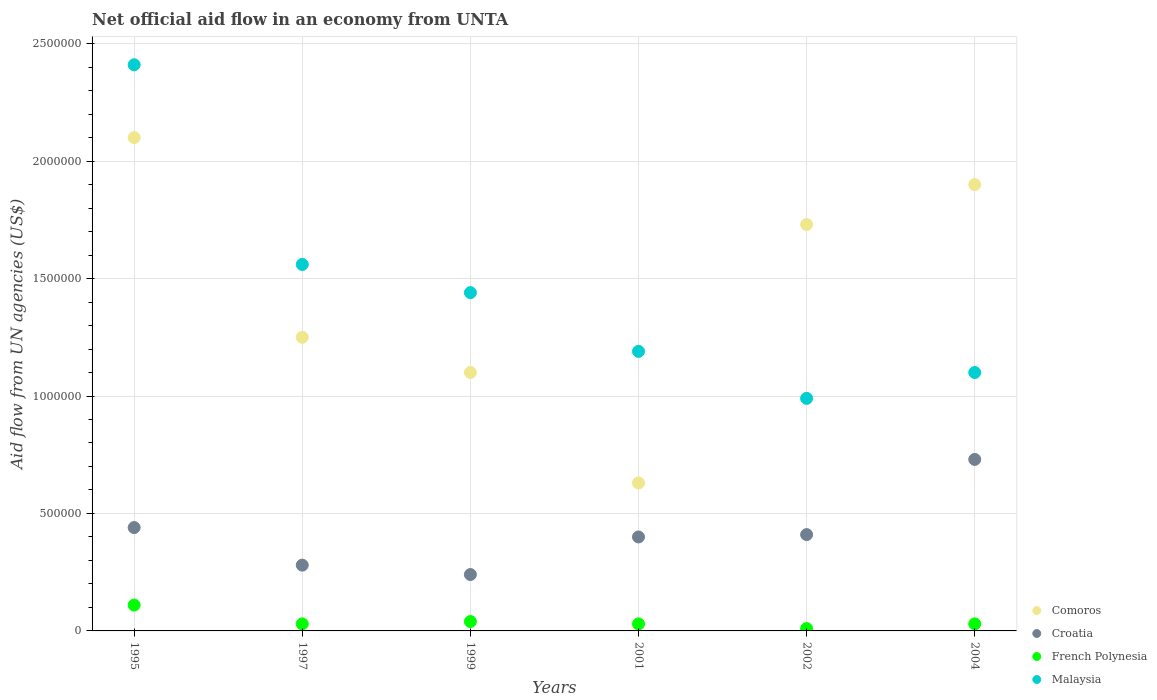How many different coloured dotlines are there?
Keep it short and to the point. 4. Is the number of dotlines equal to the number of legend labels?
Keep it short and to the point. Yes. Across all years, what is the maximum net official aid flow in Malaysia?
Your answer should be compact. 2.41e+06. Across all years, what is the minimum net official aid flow in Malaysia?
Your response must be concise. 9.90e+05. In which year was the net official aid flow in French Polynesia maximum?
Provide a short and direct response. 1995. In which year was the net official aid flow in French Polynesia minimum?
Provide a succinct answer. 2002. What is the total net official aid flow in Comoros in the graph?
Offer a very short reply. 8.71e+06. What is the difference between the net official aid flow in Malaysia in 2001 and that in 2004?
Keep it short and to the point. 9.00e+04. What is the difference between the net official aid flow in French Polynesia in 2004 and the net official aid flow in Malaysia in 1995?
Your response must be concise. -2.38e+06. What is the average net official aid flow in Croatia per year?
Your answer should be compact. 4.17e+05. In the year 1995, what is the difference between the net official aid flow in Croatia and net official aid flow in Comoros?
Provide a short and direct response. -1.66e+06. What is the ratio of the net official aid flow in Malaysia in 1999 to that in 2004?
Keep it short and to the point. 1.31. Is the net official aid flow in Croatia in 1999 less than that in 2004?
Provide a short and direct response. Yes. Is the difference between the net official aid flow in Croatia in 1995 and 2002 greater than the difference between the net official aid flow in Comoros in 1995 and 2002?
Offer a very short reply. No. What is the difference between the highest and the second highest net official aid flow in French Polynesia?
Your answer should be very brief. 7.00e+04. Is the sum of the net official aid flow in Malaysia in 1997 and 2001 greater than the maximum net official aid flow in Croatia across all years?
Your answer should be compact. Yes. Is it the case that in every year, the sum of the net official aid flow in Comoros and net official aid flow in French Polynesia  is greater than the sum of net official aid flow in Malaysia and net official aid flow in Croatia?
Ensure brevity in your answer.  No. How many years are there in the graph?
Your answer should be very brief. 6. What is the difference between two consecutive major ticks on the Y-axis?
Your answer should be very brief. 5.00e+05. Are the values on the major ticks of Y-axis written in scientific E-notation?
Your answer should be very brief. No. Does the graph contain grids?
Provide a short and direct response. Yes. Where does the legend appear in the graph?
Offer a terse response. Bottom right. How many legend labels are there?
Provide a succinct answer. 4. How are the legend labels stacked?
Provide a short and direct response. Vertical. What is the title of the graph?
Keep it short and to the point. Net official aid flow in an economy from UNTA. What is the label or title of the X-axis?
Provide a short and direct response. Years. What is the label or title of the Y-axis?
Provide a succinct answer. Aid flow from UN agencies (US$). What is the Aid flow from UN agencies (US$) of Comoros in 1995?
Make the answer very short. 2.10e+06. What is the Aid flow from UN agencies (US$) of Malaysia in 1995?
Make the answer very short. 2.41e+06. What is the Aid flow from UN agencies (US$) in Comoros in 1997?
Your answer should be compact. 1.25e+06. What is the Aid flow from UN agencies (US$) in French Polynesia in 1997?
Provide a succinct answer. 3.00e+04. What is the Aid flow from UN agencies (US$) of Malaysia in 1997?
Your response must be concise. 1.56e+06. What is the Aid flow from UN agencies (US$) in Comoros in 1999?
Your response must be concise. 1.10e+06. What is the Aid flow from UN agencies (US$) in Croatia in 1999?
Your response must be concise. 2.40e+05. What is the Aid flow from UN agencies (US$) of Malaysia in 1999?
Your answer should be very brief. 1.44e+06. What is the Aid flow from UN agencies (US$) in Comoros in 2001?
Give a very brief answer. 6.30e+05. What is the Aid flow from UN agencies (US$) in Croatia in 2001?
Provide a succinct answer. 4.00e+05. What is the Aid flow from UN agencies (US$) of Malaysia in 2001?
Your answer should be very brief. 1.19e+06. What is the Aid flow from UN agencies (US$) of Comoros in 2002?
Your answer should be compact. 1.73e+06. What is the Aid flow from UN agencies (US$) of Croatia in 2002?
Your answer should be compact. 4.10e+05. What is the Aid flow from UN agencies (US$) in Malaysia in 2002?
Offer a terse response. 9.90e+05. What is the Aid flow from UN agencies (US$) in Comoros in 2004?
Provide a short and direct response. 1.90e+06. What is the Aid flow from UN agencies (US$) of Croatia in 2004?
Give a very brief answer. 7.30e+05. What is the Aid flow from UN agencies (US$) in French Polynesia in 2004?
Ensure brevity in your answer.  3.00e+04. What is the Aid flow from UN agencies (US$) in Malaysia in 2004?
Give a very brief answer. 1.10e+06. Across all years, what is the maximum Aid flow from UN agencies (US$) of Comoros?
Your answer should be very brief. 2.10e+06. Across all years, what is the maximum Aid flow from UN agencies (US$) of Croatia?
Keep it short and to the point. 7.30e+05. Across all years, what is the maximum Aid flow from UN agencies (US$) of French Polynesia?
Your answer should be very brief. 1.10e+05. Across all years, what is the maximum Aid flow from UN agencies (US$) in Malaysia?
Keep it short and to the point. 2.41e+06. Across all years, what is the minimum Aid flow from UN agencies (US$) of Comoros?
Give a very brief answer. 6.30e+05. Across all years, what is the minimum Aid flow from UN agencies (US$) of Croatia?
Give a very brief answer. 2.40e+05. Across all years, what is the minimum Aid flow from UN agencies (US$) of Malaysia?
Your answer should be very brief. 9.90e+05. What is the total Aid flow from UN agencies (US$) in Comoros in the graph?
Provide a short and direct response. 8.71e+06. What is the total Aid flow from UN agencies (US$) in Croatia in the graph?
Keep it short and to the point. 2.50e+06. What is the total Aid flow from UN agencies (US$) in Malaysia in the graph?
Offer a terse response. 8.69e+06. What is the difference between the Aid flow from UN agencies (US$) of Comoros in 1995 and that in 1997?
Ensure brevity in your answer.  8.50e+05. What is the difference between the Aid flow from UN agencies (US$) of Malaysia in 1995 and that in 1997?
Offer a very short reply. 8.50e+05. What is the difference between the Aid flow from UN agencies (US$) of Croatia in 1995 and that in 1999?
Provide a short and direct response. 2.00e+05. What is the difference between the Aid flow from UN agencies (US$) in French Polynesia in 1995 and that in 1999?
Ensure brevity in your answer.  7.00e+04. What is the difference between the Aid flow from UN agencies (US$) of Malaysia in 1995 and that in 1999?
Ensure brevity in your answer.  9.70e+05. What is the difference between the Aid flow from UN agencies (US$) of Comoros in 1995 and that in 2001?
Your answer should be compact. 1.47e+06. What is the difference between the Aid flow from UN agencies (US$) of Croatia in 1995 and that in 2001?
Your response must be concise. 4.00e+04. What is the difference between the Aid flow from UN agencies (US$) of French Polynesia in 1995 and that in 2001?
Keep it short and to the point. 8.00e+04. What is the difference between the Aid flow from UN agencies (US$) in Malaysia in 1995 and that in 2001?
Ensure brevity in your answer.  1.22e+06. What is the difference between the Aid flow from UN agencies (US$) of Comoros in 1995 and that in 2002?
Your answer should be compact. 3.70e+05. What is the difference between the Aid flow from UN agencies (US$) in Croatia in 1995 and that in 2002?
Ensure brevity in your answer.  3.00e+04. What is the difference between the Aid flow from UN agencies (US$) of French Polynesia in 1995 and that in 2002?
Your answer should be compact. 1.00e+05. What is the difference between the Aid flow from UN agencies (US$) in Malaysia in 1995 and that in 2002?
Provide a short and direct response. 1.42e+06. What is the difference between the Aid flow from UN agencies (US$) of Comoros in 1995 and that in 2004?
Your response must be concise. 2.00e+05. What is the difference between the Aid flow from UN agencies (US$) in French Polynesia in 1995 and that in 2004?
Make the answer very short. 8.00e+04. What is the difference between the Aid flow from UN agencies (US$) in Malaysia in 1995 and that in 2004?
Make the answer very short. 1.31e+06. What is the difference between the Aid flow from UN agencies (US$) of Croatia in 1997 and that in 1999?
Make the answer very short. 4.00e+04. What is the difference between the Aid flow from UN agencies (US$) of Malaysia in 1997 and that in 1999?
Keep it short and to the point. 1.20e+05. What is the difference between the Aid flow from UN agencies (US$) of Comoros in 1997 and that in 2001?
Give a very brief answer. 6.20e+05. What is the difference between the Aid flow from UN agencies (US$) of French Polynesia in 1997 and that in 2001?
Provide a succinct answer. 0. What is the difference between the Aid flow from UN agencies (US$) in Malaysia in 1997 and that in 2001?
Ensure brevity in your answer.  3.70e+05. What is the difference between the Aid flow from UN agencies (US$) of Comoros in 1997 and that in 2002?
Ensure brevity in your answer.  -4.80e+05. What is the difference between the Aid flow from UN agencies (US$) of French Polynesia in 1997 and that in 2002?
Give a very brief answer. 2.00e+04. What is the difference between the Aid flow from UN agencies (US$) in Malaysia in 1997 and that in 2002?
Provide a succinct answer. 5.70e+05. What is the difference between the Aid flow from UN agencies (US$) of Comoros in 1997 and that in 2004?
Your answer should be compact. -6.50e+05. What is the difference between the Aid flow from UN agencies (US$) of Croatia in 1997 and that in 2004?
Keep it short and to the point. -4.50e+05. What is the difference between the Aid flow from UN agencies (US$) of Comoros in 1999 and that in 2002?
Provide a succinct answer. -6.30e+05. What is the difference between the Aid flow from UN agencies (US$) of Malaysia in 1999 and that in 2002?
Keep it short and to the point. 4.50e+05. What is the difference between the Aid flow from UN agencies (US$) of Comoros in 1999 and that in 2004?
Provide a succinct answer. -8.00e+05. What is the difference between the Aid flow from UN agencies (US$) of Croatia in 1999 and that in 2004?
Provide a succinct answer. -4.90e+05. What is the difference between the Aid flow from UN agencies (US$) of French Polynesia in 1999 and that in 2004?
Make the answer very short. 10000. What is the difference between the Aid flow from UN agencies (US$) in Malaysia in 1999 and that in 2004?
Your answer should be very brief. 3.40e+05. What is the difference between the Aid flow from UN agencies (US$) of Comoros in 2001 and that in 2002?
Provide a succinct answer. -1.10e+06. What is the difference between the Aid flow from UN agencies (US$) of French Polynesia in 2001 and that in 2002?
Make the answer very short. 2.00e+04. What is the difference between the Aid flow from UN agencies (US$) in Comoros in 2001 and that in 2004?
Provide a short and direct response. -1.27e+06. What is the difference between the Aid flow from UN agencies (US$) in Croatia in 2001 and that in 2004?
Your answer should be compact. -3.30e+05. What is the difference between the Aid flow from UN agencies (US$) of French Polynesia in 2001 and that in 2004?
Provide a succinct answer. 0. What is the difference between the Aid flow from UN agencies (US$) of Malaysia in 2001 and that in 2004?
Ensure brevity in your answer.  9.00e+04. What is the difference between the Aid flow from UN agencies (US$) in Comoros in 2002 and that in 2004?
Give a very brief answer. -1.70e+05. What is the difference between the Aid flow from UN agencies (US$) of Croatia in 2002 and that in 2004?
Give a very brief answer. -3.20e+05. What is the difference between the Aid flow from UN agencies (US$) of Comoros in 1995 and the Aid flow from UN agencies (US$) of Croatia in 1997?
Offer a very short reply. 1.82e+06. What is the difference between the Aid flow from UN agencies (US$) of Comoros in 1995 and the Aid flow from UN agencies (US$) of French Polynesia in 1997?
Your answer should be compact. 2.07e+06. What is the difference between the Aid flow from UN agencies (US$) of Comoros in 1995 and the Aid flow from UN agencies (US$) of Malaysia in 1997?
Offer a very short reply. 5.40e+05. What is the difference between the Aid flow from UN agencies (US$) of Croatia in 1995 and the Aid flow from UN agencies (US$) of French Polynesia in 1997?
Your answer should be compact. 4.10e+05. What is the difference between the Aid flow from UN agencies (US$) in Croatia in 1995 and the Aid flow from UN agencies (US$) in Malaysia in 1997?
Your answer should be compact. -1.12e+06. What is the difference between the Aid flow from UN agencies (US$) in French Polynesia in 1995 and the Aid flow from UN agencies (US$) in Malaysia in 1997?
Make the answer very short. -1.45e+06. What is the difference between the Aid flow from UN agencies (US$) in Comoros in 1995 and the Aid flow from UN agencies (US$) in Croatia in 1999?
Provide a succinct answer. 1.86e+06. What is the difference between the Aid flow from UN agencies (US$) of Comoros in 1995 and the Aid flow from UN agencies (US$) of French Polynesia in 1999?
Provide a succinct answer. 2.06e+06. What is the difference between the Aid flow from UN agencies (US$) in Comoros in 1995 and the Aid flow from UN agencies (US$) in Malaysia in 1999?
Provide a succinct answer. 6.60e+05. What is the difference between the Aid flow from UN agencies (US$) of Croatia in 1995 and the Aid flow from UN agencies (US$) of French Polynesia in 1999?
Give a very brief answer. 4.00e+05. What is the difference between the Aid flow from UN agencies (US$) in French Polynesia in 1995 and the Aid flow from UN agencies (US$) in Malaysia in 1999?
Provide a succinct answer. -1.33e+06. What is the difference between the Aid flow from UN agencies (US$) of Comoros in 1995 and the Aid flow from UN agencies (US$) of Croatia in 2001?
Make the answer very short. 1.70e+06. What is the difference between the Aid flow from UN agencies (US$) of Comoros in 1995 and the Aid flow from UN agencies (US$) of French Polynesia in 2001?
Keep it short and to the point. 2.07e+06. What is the difference between the Aid flow from UN agencies (US$) in Comoros in 1995 and the Aid flow from UN agencies (US$) in Malaysia in 2001?
Offer a very short reply. 9.10e+05. What is the difference between the Aid flow from UN agencies (US$) of Croatia in 1995 and the Aid flow from UN agencies (US$) of French Polynesia in 2001?
Offer a very short reply. 4.10e+05. What is the difference between the Aid flow from UN agencies (US$) in Croatia in 1995 and the Aid flow from UN agencies (US$) in Malaysia in 2001?
Your answer should be compact. -7.50e+05. What is the difference between the Aid flow from UN agencies (US$) of French Polynesia in 1995 and the Aid flow from UN agencies (US$) of Malaysia in 2001?
Your answer should be compact. -1.08e+06. What is the difference between the Aid flow from UN agencies (US$) in Comoros in 1995 and the Aid flow from UN agencies (US$) in Croatia in 2002?
Your answer should be compact. 1.69e+06. What is the difference between the Aid flow from UN agencies (US$) in Comoros in 1995 and the Aid flow from UN agencies (US$) in French Polynesia in 2002?
Make the answer very short. 2.09e+06. What is the difference between the Aid flow from UN agencies (US$) in Comoros in 1995 and the Aid flow from UN agencies (US$) in Malaysia in 2002?
Make the answer very short. 1.11e+06. What is the difference between the Aid flow from UN agencies (US$) in Croatia in 1995 and the Aid flow from UN agencies (US$) in Malaysia in 2002?
Your answer should be very brief. -5.50e+05. What is the difference between the Aid flow from UN agencies (US$) of French Polynesia in 1995 and the Aid flow from UN agencies (US$) of Malaysia in 2002?
Your answer should be very brief. -8.80e+05. What is the difference between the Aid flow from UN agencies (US$) in Comoros in 1995 and the Aid flow from UN agencies (US$) in Croatia in 2004?
Offer a terse response. 1.37e+06. What is the difference between the Aid flow from UN agencies (US$) in Comoros in 1995 and the Aid flow from UN agencies (US$) in French Polynesia in 2004?
Your answer should be compact. 2.07e+06. What is the difference between the Aid flow from UN agencies (US$) of Croatia in 1995 and the Aid flow from UN agencies (US$) of French Polynesia in 2004?
Your response must be concise. 4.10e+05. What is the difference between the Aid flow from UN agencies (US$) of Croatia in 1995 and the Aid flow from UN agencies (US$) of Malaysia in 2004?
Your answer should be very brief. -6.60e+05. What is the difference between the Aid flow from UN agencies (US$) of French Polynesia in 1995 and the Aid flow from UN agencies (US$) of Malaysia in 2004?
Your response must be concise. -9.90e+05. What is the difference between the Aid flow from UN agencies (US$) of Comoros in 1997 and the Aid flow from UN agencies (US$) of Croatia in 1999?
Provide a succinct answer. 1.01e+06. What is the difference between the Aid flow from UN agencies (US$) of Comoros in 1997 and the Aid flow from UN agencies (US$) of French Polynesia in 1999?
Your answer should be compact. 1.21e+06. What is the difference between the Aid flow from UN agencies (US$) of Comoros in 1997 and the Aid flow from UN agencies (US$) of Malaysia in 1999?
Your response must be concise. -1.90e+05. What is the difference between the Aid flow from UN agencies (US$) of Croatia in 1997 and the Aid flow from UN agencies (US$) of Malaysia in 1999?
Provide a short and direct response. -1.16e+06. What is the difference between the Aid flow from UN agencies (US$) of French Polynesia in 1997 and the Aid flow from UN agencies (US$) of Malaysia in 1999?
Provide a succinct answer. -1.41e+06. What is the difference between the Aid flow from UN agencies (US$) in Comoros in 1997 and the Aid flow from UN agencies (US$) in Croatia in 2001?
Provide a short and direct response. 8.50e+05. What is the difference between the Aid flow from UN agencies (US$) in Comoros in 1997 and the Aid flow from UN agencies (US$) in French Polynesia in 2001?
Provide a succinct answer. 1.22e+06. What is the difference between the Aid flow from UN agencies (US$) in Croatia in 1997 and the Aid flow from UN agencies (US$) in Malaysia in 2001?
Make the answer very short. -9.10e+05. What is the difference between the Aid flow from UN agencies (US$) of French Polynesia in 1997 and the Aid flow from UN agencies (US$) of Malaysia in 2001?
Your response must be concise. -1.16e+06. What is the difference between the Aid flow from UN agencies (US$) in Comoros in 1997 and the Aid flow from UN agencies (US$) in Croatia in 2002?
Provide a short and direct response. 8.40e+05. What is the difference between the Aid flow from UN agencies (US$) in Comoros in 1997 and the Aid flow from UN agencies (US$) in French Polynesia in 2002?
Offer a terse response. 1.24e+06. What is the difference between the Aid flow from UN agencies (US$) of Comoros in 1997 and the Aid flow from UN agencies (US$) of Malaysia in 2002?
Ensure brevity in your answer.  2.60e+05. What is the difference between the Aid flow from UN agencies (US$) of Croatia in 1997 and the Aid flow from UN agencies (US$) of French Polynesia in 2002?
Make the answer very short. 2.70e+05. What is the difference between the Aid flow from UN agencies (US$) of Croatia in 1997 and the Aid flow from UN agencies (US$) of Malaysia in 2002?
Make the answer very short. -7.10e+05. What is the difference between the Aid flow from UN agencies (US$) in French Polynesia in 1997 and the Aid flow from UN agencies (US$) in Malaysia in 2002?
Keep it short and to the point. -9.60e+05. What is the difference between the Aid flow from UN agencies (US$) in Comoros in 1997 and the Aid flow from UN agencies (US$) in Croatia in 2004?
Your answer should be compact. 5.20e+05. What is the difference between the Aid flow from UN agencies (US$) of Comoros in 1997 and the Aid flow from UN agencies (US$) of French Polynesia in 2004?
Keep it short and to the point. 1.22e+06. What is the difference between the Aid flow from UN agencies (US$) in Croatia in 1997 and the Aid flow from UN agencies (US$) in French Polynesia in 2004?
Make the answer very short. 2.50e+05. What is the difference between the Aid flow from UN agencies (US$) in Croatia in 1997 and the Aid flow from UN agencies (US$) in Malaysia in 2004?
Ensure brevity in your answer.  -8.20e+05. What is the difference between the Aid flow from UN agencies (US$) of French Polynesia in 1997 and the Aid flow from UN agencies (US$) of Malaysia in 2004?
Your response must be concise. -1.07e+06. What is the difference between the Aid flow from UN agencies (US$) of Comoros in 1999 and the Aid flow from UN agencies (US$) of French Polynesia in 2001?
Offer a terse response. 1.07e+06. What is the difference between the Aid flow from UN agencies (US$) in Croatia in 1999 and the Aid flow from UN agencies (US$) in Malaysia in 2001?
Offer a very short reply. -9.50e+05. What is the difference between the Aid flow from UN agencies (US$) of French Polynesia in 1999 and the Aid flow from UN agencies (US$) of Malaysia in 2001?
Make the answer very short. -1.15e+06. What is the difference between the Aid flow from UN agencies (US$) in Comoros in 1999 and the Aid flow from UN agencies (US$) in Croatia in 2002?
Your answer should be compact. 6.90e+05. What is the difference between the Aid flow from UN agencies (US$) of Comoros in 1999 and the Aid flow from UN agencies (US$) of French Polynesia in 2002?
Your answer should be very brief. 1.09e+06. What is the difference between the Aid flow from UN agencies (US$) in Croatia in 1999 and the Aid flow from UN agencies (US$) in French Polynesia in 2002?
Provide a short and direct response. 2.30e+05. What is the difference between the Aid flow from UN agencies (US$) in Croatia in 1999 and the Aid flow from UN agencies (US$) in Malaysia in 2002?
Your answer should be compact. -7.50e+05. What is the difference between the Aid flow from UN agencies (US$) in French Polynesia in 1999 and the Aid flow from UN agencies (US$) in Malaysia in 2002?
Give a very brief answer. -9.50e+05. What is the difference between the Aid flow from UN agencies (US$) in Comoros in 1999 and the Aid flow from UN agencies (US$) in Croatia in 2004?
Make the answer very short. 3.70e+05. What is the difference between the Aid flow from UN agencies (US$) of Comoros in 1999 and the Aid flow from UN agencies (US$) of French Polynesia in 2004?
Provide a short and direct response. 1.07e+06. What is the difference between the Aid flow from UN agencies (US$) in Croatia in 1999 and the Aid flow from UN agencies (US$) in French Polynesia in 2004?
Your answer should be compact. 2.10e+05. What is the difference between the Aid flow from UN agencies (US$) of Croatia in 1999 and the Aid flow from UN agencies (US$) of Malaysia in 2004?
Your answer should be compact. -8.60e+05. What is the difference between the Aid flow from UN agencies (US$) of French Polynesia in 1999 and the Aid flow from UN agencies (US$) of Malaysia in 2004?
Your response must be concise. -1.06e+06. What is the difference between the Aid flow from UN agencies (US$) of Comoros in 2001 and the Aid flow from UN agencies (US$) of Croatia in 2002?
Give a very brief answer. 2.20e+05. What is the difference between the Aid flow from UN agencies (US$) of Comoros in 2001 and the Aid flow from UN agencies (US$) of French Polynesia in 2002?
Your answer should be very brief. 6.20e+05. What is the difference between the Aid flow from UN agencies (US$) in Comoros in 2001 and the Aid flow from UN agencies (US$) in Malaysia in 2002?
Your answer should be compact. -3.60e+05. What is the difference between the Aid flow from UN agencies (US$) in Croatia in 2001 and the Aid flow from UN agencies (US$) in French Polynesia in 2002?
Your answer should be very brief. 3.90e+05. What is the difference between the Aid flow from UN agencies (US$) in Croatia in 2001 and the Aid flow from UN agencies (US$) in Malaysia in 2002?
Offer a terse response. -5.90e+05. What is the difference between the Aid flow from UN agencies (US$) in French Polynesia in 2001 and the Aid flow from UN agencies (US$) in Malaysia in 2002?
Offer a very short reply. -9.60e+05. What is the difference between the Aid flow from UN agencies (US$) in Comoros in 2001 and the Aid flow from UN agencies (US$) in French Polynesia in 2004?
Make the answer very short. 6.00e+05. What is the difference between the Aid flow from UN agencies (US$) in Comoros in 2001 and the Aid flow from UN agencies (US$) in Malaysia in 2004?
Provide a short and direct response. -4.70e+05. What is the difference between the Aid flow from UN agencies (US$) of Croatia in 2001 and the Aid flow from UN agencies (US$) of Malaysia in 2004?
Keep it short and to the point. -7.00e+05. What is the difference between the Aid flow from UN agencies (US$) of French Polynesia in 2001 and the Aid flow from UN agencies (US$) of Malaysia in 2004?
Your response must be concise. -1.07e+06. What is the difference between the Aid flow from UN agencies (US$) in Comoros in 2002 and the Aid flow from UN agencies (US$) in French Polynesia in 2004?
Provide a succinct answer. 1.70e+06. What is the difference between the Aid flow from UN agencies (US$) of Comoros in 2002 and the Aid flow from UN agencies (US$) of Malaysia in 2004?
Provide a short and direct response. 6.30e+05. What is the difference between the Aid flow from UN agencies (US$) in Croatia in 2002 and the Aid flow from UN agencies (US$) in Malaysia in 2004?
Offer a very short reply. -6.90e+05. What is the difference between the Aid flow from UN agencies (US$) in French Polynesia in 2002 and the Aid flow from UN agencies (US$) in Malaysia in 2004?
Offer a terse response. -1.09e+06. What is the average Aid flow from UN agencies (US$) of Comoros per year?
Provide a succinct answer. 1.45e+06. What is the average Aid flow from UN agencies (US$) of Croatia per year?
Your answer should be very brief. 4.17e+05. What is the average Aid flow from UN agencies (US$) in French Polynesia per year?
Ensure brevity in your answer.  4.17e+04. What is the average Aid flow from UN agencies (US$) in Malaysia per year?
Make the answer very short. 1.45e+06. In the year 1995, what is the difference between the Aid flow from UN agencies (US$) in Comoros and Aid flow from UN agencies (US$) in Croatia?
Offer a terse response. 1.66e+06. In the year 1995, what is the difference between the Aid flow from UN agencies (US$) in Comoros and Aid flow from UN agencies (US$) in French Polynesia?
Keep it short and to the point. 1.99e+06. In the year 1995, what is the difference between the Aid flow from UN agencies (US$) of Comoros and Aid flow from UN agencies (US$) of Malaysia?
Provide a succinct answer. -3.10e+05. In the year 1995, what is the difference between the Aid flow from UN agencies (US$) of Croatia and Aid flow from UN agencies (US$) of Malaysia?
Provide a succinct answer. -1.97e+06. In the year 1995, what is the difference between the Aid flow from UN agencies (US$) of French Polynesia and Aid flow from UN agencies (US$) of Malaysia?
Keep it short and to the point. -2.30e+06. In the year 1997, what is the difference between the Aid flow from UN agencies (US$) of Comoros and Aid flow from UN agencies (US$) of Croatia?
Make the answer very short. 9.70e+05. In the year 1997, what is the difference between the Aid flow from UN agencies (US$) in Comoros and Aid flow from UN agencies (US$) in French Polynesia?
Provide a short and direct response. 1.22e+06. In the year 1997, what is the difference between the Aid flow from UN agencies (US$) in Comoros and Aid flow from UN agencies (US$) in Malaysia?
Give a very brief answer. -3.10e+05. In the year 1997, what is the difference between the Aid flow from UN agencies (US$) of Croatia and Aid flow from UN agencies (US$) of Malaysia?
Your response must be concise. -1.28e+06. In the year 1997, what is the difference between the Aid flow from UN agencies (US$) of French Polynesia and Aid flow from UN agencies (US$) of Malaysia?
Your answer should be very brief. -1.53e+06. In the year 1999, what is the difference between the Aid flow from UN agencies (US$) of Comoros and Aid flow from UN agencies (US$) of Croatia?
Provide a succinct answer. 8.60e+05. In the year 1999, what is the difference between the Aid flow from UN agencies (US$) in Comoros and Aid flow from UN agencies (US$) in French Polynesia?
Give a very brief answer. 1.06e+06. In the year 1999, what is the difference between the Aid flow from UN agencies (US$) in Croatia and Aid flow from UN agencies (US$) in French Polynesia?
Keep it short and to the point. 2.00e+05. In the year 1999, what is the difference between the Aid flow from UN agencies (US$) in Croatia and Aid flow from UN agencies (US$) in Malaysia?
Offer a very short reply. -1.20e+06. In the year 1999, what is the difference between the Aid flow from UN agencies (US$) in French Polynesia and Aid flow from UN agencies (US$) in Malaysia?
Offer a very short reply. -1.40e+06. In the year 2001, what is the difference between the Aid flow from UN agencies (US$) in Comoros and Aid flow from UN agencies (US$) in French Polynesia?
Give a very brief answer. 6.00e+05. In the year 2001, what is the difference between the Aid flow from UN agencies (US$) in Comoros and Aid flow from UN agencies (US$) in Malaysia?
Your response must be concise. -5.60e+05. In the year 2001, what is the difference between the Aid flow from UN agencies (US$) of Croatia and Aid flow from UN agencies (US$) of Malaysia?
Make the answer very short. -7.90e+05. In the year 2001, what is the difference between the Aid flow from UN agencies (US$) of French Polynesia and Aid flow from UN agencies (US$) of Malaysia?
Provide a succinct answer. -1.16e+06. In the year 2002, what is the difference between the Aid flow from UN agencies (US$) in Comoros and Aid flow from UN agencies (US$) in Croatia?
Your answer should be very brief. 1.32e+06. In the year 2002, what is the difference between the Aid flow from UN agencies (US$) in Comoros and Aid flow from UN agencies (US$) in French Polynesia?
Offer a very short reply. 1.72e+06. In the year 2002, what is the difference between the Aid flow from UN agencies (US$) in Comoros and Aid flow from UN agencies (US$) in Malaysia?
Offer a very short reply. 7.40e+05. In the year 2002, what is the difference between the Aid flow from UN agencies (US$) in Croatia and Aid flow from UN agencies (US$) in French Polynesia?
Offer a very short reply. 4.00e+05. In the year 2002, what is the difference between the Aid flow from UN agencies (US$) in Croatia and Aid flow from UN agencies (US$) in Malaysia?
Provide a short and direct response. -5.80e+05. In the year 2002, what is the difference between the Aid flow from UN agencies (US$) of French Polynesia and Aid flow from UN agencies (US$) of Malaysia?
Your response must be concise. -9.80e+05. In the year 2004, what is the difference between the Aid flow from UN agencies (US$) in Comoros and Aid flow from UN agencies (US$) in Croatia?
Give a very brief answer. 1.17e+06. In the year 2004, what is the difference between the Aid flow from UN agencies (US$) in Comoros and Aid flow from UN agencies (US$) in French Polynesia?
Ensure brevity in your answer.  1.87e+06. In the year 2004, what is the difference between the Aid flow from UN agencies (US$) in Comoros and Aid flow from UN agencies (US$) in Malaysia?
Ensure brevity in your answer.  8.00e+05. In the year 2004, what is the difference between the Aid flow from UN agencies (US$) of Croatia and Aid flow from UN agencies (US$) of Malaysia?
Keep it short and to the point. -3.70e+05. In the year 2004, what is the difference between the Aid flow from UN agencies (US$) of French Polynesia and Aid flow from UN agencies (US$) of Malaysia?
Provide a short and direct response. -1.07e+06. What is the ratio of the Aid flow from UN agencies (US$) in Comoros in 1995 to that in 1997?
Provide a short and direct response. 1.68. What is the ratio of the Aid flow from UN agencies (US$) of Croatia in 1995 to that in 1997?
Make the answer very short. 1.57. What is the ratio of the Aid flow from UN agencies (US$) in French Polynesia in 1995 to that in 1997?
Provide a succinct answer. 3.67. What is the ratio of the Aid flow from UN agencies (US$) of Malaysia in 1995 to that in 1997?
Provide a short and direct response. 1.54. What is the ratio of the Aid flow from UN agencies (US$) of Comoros in 1995 to that in 1999?
Give a very brief answer. 1.91. What is the ratio of the Aid flow from UN agencies (US$) of Croatia in 1995 to that in 1999?
Ensure brevity in your answer.  1.83. What is the ratio of the Aid flow from UN agencies (US$) of French Polynesia in 1995 to that in 1999?
Offer a terse response. 2.75. What is the ratio of the Aid flow from UN agencies (US$) in Malaysia in 1995 to that in 1999?
Your answer should be very brief. 1.67. What is the ratio of the Aid flow from UN agencies (US$) of Croatia in 1995 to that in 2001?
Ensure brevity in your answer.  1.1. What is the ratio of the Aid flow from UN agencies (US$) in French Polynesia in 1995 to that in 2001?
Your response must be concise. 3.67. What is the ratio of the Aid flow from UN agencies (US$) in Malaysia in 1995 to that in 2001?
Ensure brevity in your answer.  2.03. What is the ratio of the Aid flow from UN agencies (US$) of Comoros in 1995 to that in 2002?
Offer a very short reply. 1.21. What is the ratio of the Aid flow from UN agencies (US$) in Croatia in 1995 to that in 2002?
Ensure brevity in your answer.  1.07. What is the ratio of the Aid flow from UN agencies (US$) in Malaysia in 1995 to that in 2002?
Provide a short and direct response. 2.43. What is the ratio of the Aid flow from UN agencies (US$) of Comoros in 1995 to that in 2004?
Offer a very short reply. 1.11. What is the ratio of the Aid flow from UN agencies (US$) in Croatia in 1995 to that in 2004?
Ensure brevity in your answer.  0.6. What is the ratio of the Aid flow from UN agencies (US$) in French Polynesia in 1995 to that in 2004?
Your answer should be compact. 3.67. What is the ratio of the Aid flow from UN agencies (US$) in Malaysia in 1995 to that in 2004?
Keep it short and to the point. 2.19. What is the ratio of the Aid flow from UN agencies (US$) in Comoros in 1997 to that in 1999?
Your answer should be very brief. 1.14. What is the ratio of the Aid flow from UN agencies (US$) in Croatia in 1997 to that in 1999?
Provide a succinct answer. 1.17. What is the ratio of the Aid flow from UN agencies (US$) in Comoros in 1997 to that in 2001?
Offer a terse response. 1.98. What is the ratio of the Aid flow from UN agencies (US$) of French Polynesia in 1997 to that in 2001?
Offer a very short reply. 1. What is the ratio of the Aid flow from UN agencies (US$) in Malaysia in 1997 to that in 2001?
Offer a very short reply. 1.31. What is the ratio of the Aid flow from UN agencies (US$) of Comoros in 1997 to that in 2002?
Your answer should be compact. 0.72. What is the ratio of the Aid flow from UN agencies (US$) of Croatia in 1997 to that in 2002?
Your answer should be very brief. 0.68. What is the ratio of the Aid flow from UN agencies (US$) in Malaysia in 1997 to that in 2002?
Keep it short and to the point. 1.58. What is the ratio of the Aid flow from UN agencies (US$) of Comoros in 1997 to that in 2004?
Provide a short and direct response. 0.66. What is the ratio of the Aid flow from UN agencies (US$) in Croatia in 1997 to that in 2004?
Offer a very short reply. 0.38. What is the ratio of the Aid flow from UN agencies (US$) in French Polynesia in 1997 to that in 2004?
Keep it short and to the point. 1. What is the ratio of the Aid flow from UN agencies (US$) in Malaysia in 1997 to that in 2004?
Give a very brief answer. 1.42. What is the ratio of the Aid flow from UN agencies (US$) in Comoros in 1999 to that in 2001?
Offer a very short reply. 1.75. What is the ratio of the Aid flow from UN agencies (US$) of Croatia in 1999 to that in 2001?
Keep it short and to the point. 0.6. What is the ratio of the Aid flow from UN agencies (US$) in French Polynesia in 1999 to that in 2001?
Ensure brevity in your answer.  1.33. What is the ratio of the Aid flow from UN agencies (US$) of Malaysia in 1999 to that in 2001?
Offer a very short reply. 1.21. What is the ratio of the Aid flow from UN agencies (US$) in Comoros in 1999 to that in 2002?
Offer a very short reply. 0.64. What is the ratio of the Aid flow from UN agencies (US$) of Croatia in 1999 to that in 2002?
Provide a short and direct response. 0.59. What is the ratio of the Aid flow from UN agencies (US$) of French Polynesia in 1999 to that in 2002?
Ensure brevity in your answer.  4. What is the ratio of the Aid flow from UN agencies (US$) in Malaysia in 1999 to that in 2002?
Keep it short and to the point. 1.45. What is the ratio of the Aid flow from UN agencies (US$) of Comoros in 1999 to that in 2004?
Your answer should be compact. 0.58. What is the ratio of the Aid flow from UN agencies (US$) of Croatia in 1999 to that in 2004?
Offer a very short reply. 0.33. What is the ratio of the Aid flow from UN agencies (US$) of French Polynesia in 1999 to that in 2004?
Your response must be concise. 1.33. What is the ratio of the Aid flow from UN agencies (US$) of Malaysia in 1999 to that in 2004?
Give a very brief answer. 1.31. What is the ratio of the Aid flow from UN agencies (US$) of Comoros in 2001 to that in 2002?
Make the answer very short. 0.36. What is the ratio of the Aid flow from UN agencies (US$) in Croatia in 2001 to that in 2002?
Your answer should be very brief. 0.98. What is the ratio of the Aid flow from UN agencies (US$) of Malaysia in 2001 to that in 2002?
Ensure brevity in your answer.  1.2. What is the ratio of the Aid flow from UN agencies (US$) of Comoros in 2001 to that in 2004?
Your answer should be compact. 0.33. What is the ratio of the Aid flow from UN agencies (US$) of Croatia in 2001 to that in 2004?
Keep it short and to the point. 0.55. What is the ratio of the Aid flow from UN agencies (US$) of French Polynesia in 2001 to that in 2004?
Your response must be concise. 1. What is the ratio of the Aid flow from UN agencies (US$) in Malaysia in 2001 to that in 2004?
Provide a short and direct response. 1.08. What is the ratio of the Aid flow from UN agencies (US$) of Comoros in 2002 to that in 2004?
Your answer should be compact. 0.91. What is the ratio of the Aid flow from UN agencies (US$) of Croatia in 2002 to that in 2004?
Give a very brief answer. 0.56. What is the difference between the highest and the second highest Aid flow from UN agencies (US$) of Croatia?
Your response must be concise. 2.90e+05. What is the difference between the highest and the second highest Aid flow from UN agencies (US$) of Malaysia?
Keep it short and to the point. 8.50e+05. What is the difference between the highest and the lowest Aid flow from UN agencies (US$) of Comoros?
Ensure brevity in your answer.  1.47e+06. What is the difference between the highest and the lowest Aid flow from UN agencies (US$) of Malaysia?
Offer a very short reply. 1.42e+06. 